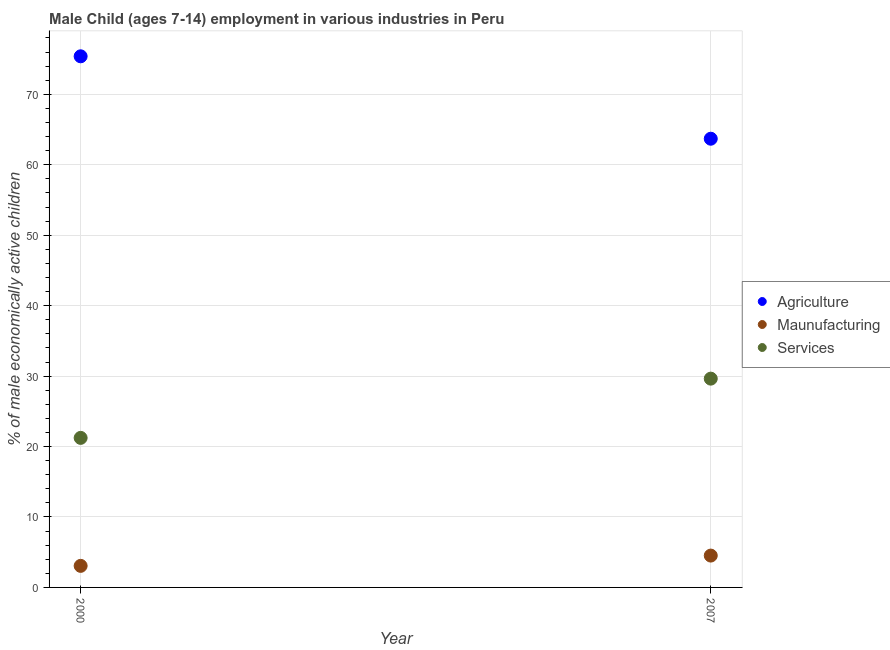How many different coloured dotlines are there?
Provide a succinct answer. 3. Is the number of dotlines equal to the number of legend labels?
Offer a terse response. Yes. What is the percentage of economically active children in agriculture in 2000?
Offer a very short reply. 75.4. Across all years, what is the maximum percentage of economically active children in manufacturing?
Your answer should be compact. 4.52. Across all years, what is the minimum percentage of economically active children in manufacturing?
Ensure brevity in your answer.  3.06. In which year was the percentage of economically active children in agriculture maximum?
Make the answer very short. 2000. What is the total percentage of economically active children in manufacturing in the graph?
Give a very brief answer. 7.58. What is the difference between the percentage of economically active children in agriculture in 2000 and that in 2007?
Ensure brevity in your answer.  11.7. What is the difference between the percentage of economically active children in agriculture in 2007 and the percentage of economically active children in manufacturing in 2000?
Offer a very short reply. 60.64. What is the average percentage of economically active children in agriculture per year?
Make the answer very short. 69.55. In the year 2000, what is the difference between the percentage of economically active children in services and percentage of economically active children in manufacturing?
Keep it short and to the point. 18.17. In how many years, is the percentage of economically active children in services greater than 4 %?
Your answer should be compact. 2. What is the ratio of the percentage of economically active children in agriculture in 2000 to that in 2007?
Your answer should be very brief. 1.18. Is the percentage of economically active children in manufacturing in 2000 less than that in 2007?
Give a very brief answer. Yes. Does the percentage of economically active children in agriculture monotonically increase over the years?
Offer a terse response. No. Is the percentage of economically active children in agriculture strictly greater than the percentage of economically active children in services over the years?
Keep it short and to the point. Yes. Is the percentage of economically active children in agriculture strictly less than the percentage of economically active children in manufacturing over the years?
Your answer should be compact. No. What is the difference between two consecutive major ticks on the Y-axis?
Provide a succinct answer. 10. Does the graph contain any zero values?
Provide a succinct answer. No. How many legend labels are there?
Your answer should be very brief. 3. What is the title of the graph?
Your answer should be very brief. Male Child (ages 7-14) employment in various industries in Peru. Does "Social Protection" appear as one of the legend labels in the graph?
Provide a succinct answer. No. What is the label or title of the X-axis?
Offer a very short reply. Year. What is the label or title of the Y-axis?
Keep it short and to the point. % of male economically active children. What is the % of male economically active children in Agriculture in 2000?
Give a very brief answer. 75.4. What is the % of male economically active children of Maunufacturing in 2000?
Keep it short and to the point. 3.06. What is the % of male economically active children of Services in 2000?
Offer a very short reply. 21.23. What is the % of male economically active children in Agriculture in 2007?
Your response must be concise. 63.7. What is the % of male economically active children in Maunufacturing in 2007?
Provide a short and direct response. 4.52. What is the % of male economically active children of Services in 2007?
Provide a succinct answer. 29.64. Across all years, what is the maximum % of male economically active children in Agriculture?
Offer a very short reply. 75.4. Across all years, what is the maximum % of male economically active children of Maunufacturing?
Offer a terse response. 4.52. Across all years, what is the maximum % of male economically active children of Services?
Offer a very short reply. 29.64. Across all years, what is the minimum % of male economically active children of Agriculture?
Give a very brief answer. 63.7. Across all years, what is the minimum % of male economically active children in Maunufacturing?
Keep it short and to the point. 3.06. Across all years, what is the minimum % of male economically active children in Services?
Keep it short and to the point. 21.23. What is the total % of male economically active children in Agriculture in the graph?
Your answer should be very brief. 139.1. What is the total % of male economically active children in Maunufacturing in the graph?
Your response must be concise. 7.58. What is the total % of male economically active children of Services in the graph?
Your answer should be compact. 50.87. What is the difference between the % of male economically active children of Maunufacturing in 2000 and that in 2007?
Keep it short and to the point. -1.46. What is the difference between the % of male economically active children of Services in 2000 and that in 2007?
Keep it short and to the point. -8.41. What is the difference between the % of male economically active children of Agriculture in 2000 and the % of male economically active children of Maunufacturing in 2007?
Make the answer very short. 70.88. What is the difference between the % of male economically active children of Agriculture in 2000 and the % of male economically active children of Services in 2007?
Your answer should be compact. 45.76. What is the difference between the % of male economically active children in Maunufacturing in 2000 and the % of male economically active children in Services in 2007?
Offer a very short reply. -26.58. What is the average % of male economically active children in Agriculture per year?
Keep it short and to the point. 69.55. What is the average % of male economically active children in Maunufacturing per year?
Ensure brevity in your answer.  3.79. What is the average % of male economically active children in Services per year?
Offer a very short reply. 25.43. In the year 2000, what is the difference between the % of male economically active children in Agriculture and % of male economically active children in Maunufacturing?
Provide a succinct answer. 72.34. In the year 2000, what is the difference between the % of male economically active children in Agriculture and % of male economically active children in Services?
Offer a very short reply. 54.17. In the year 2000, what is the difference between the % of male economically active children in Maunufacturing and % of male economically active children in Services?
Your answer should be very brief. -18.17. In the year 2007, what is the difference between the % of male economically active children of Agriculture and % of male economically active children of Maunufacturing?
Give a very brief answer. 59.18. In the year 2007, what is the difference between the % of male economically active children of Agriculture and % of male economically active children of Services?
Provide a succinct answer. 34.06. In the year 2007, what is the difference between the % of male economically active children of Maunufacturing and % of male economically active children of Services?
Offer a very short reply. -25.12. What is the ratio of the % of male economically active children of Agriculture in 2000 to that in 2007?
Your response must be concise. 1.18. What is the ratio of the % of male economically active children in Maunufacturing in 2000 to that in 2007?
Provide a succinct answer. 0.68. What is the ratio of the % of male economically active children of Services in 2000 to that in 2007?
Provide a succinct answer. 0.72. What is the difference between the highest and the second highest % of male economically active children of Agriculture?
Make the answer very short. 11.7. What is the difference between the highest and the second highest % of male economically active children in Maunufacturing?
Keep it short and to the point. 1.46. What is the difference between the highest and the second highest % of male economically active children in Services?
Offer a terse response. 8.41. What is the difference between the highest and the lowest % of male economically active children of Maunufacturing?
Ensure brevity in your answer.  1.46. What is the difference between the highest and the lowest % of male economically active children in Services?
Provide a short and direct response. 8.41. 